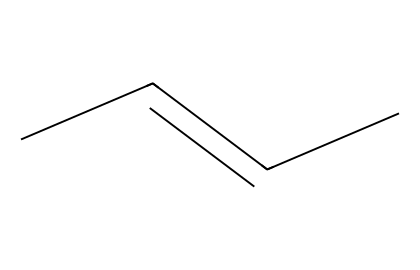What is the ratio of carbon to hydrogen atoms in this chemical? The chemical structure CC=CC indicates there are 4 carbon atoms (C) and 6 hydrogen atoms (H). The ratio of carbon to hydrogen is 4:6, which simplifies to 2:3.
Answer: 2:3 How many double bonds are present in this structure? The structure CC=CC contains one double bond between the two carbon atoms marked by the "=" sign.
Answer: 1 What type of geometric isomer can this structure exhibit? Since the structure CC=CC has a double bond and different groups attached to the adjacent carbon atoms, it can exhibit cis and trans geometric isomerism.
Answer: cis and trans What is the overall molecular formula of this compound? The structure CC=CC consists of 4 carbon atoms and 6 hydrogen atoms, which together gives the molecular formula C4H6.
Answer: C4H6 Does this molecule have any chiral centers? A chiral center is typically a carbon atom bonded to four different groups. In this structure, there are no carbon atoms fitting this definition, so the molecule does not have chiral centers.
Answer: No 